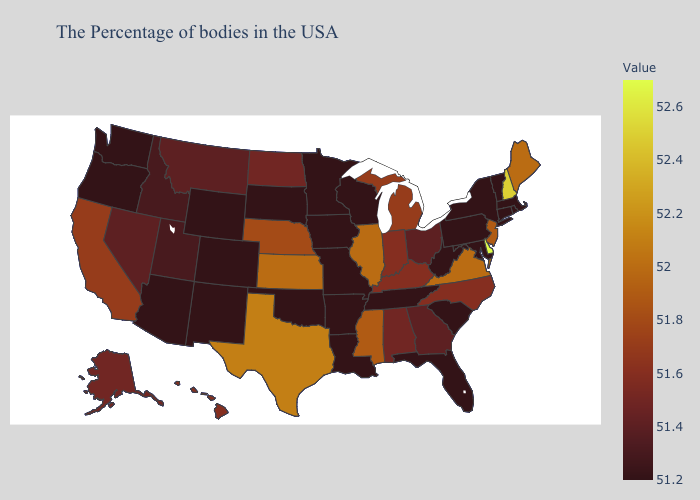Among the states that border Missouri , which have the highest value?
Quick response, please. Illinois, Kansas. Does the map have missing data?
Quick response, please. No. Which states have the lowest value in the USA?
Concise answer only. Massachusetts, Rhode Island, Vermont, Connecticut, New York, Maryland, Pennsylvania, South Carolina, West Virginia, Florida, Tennessee, Wisconsin, Louisiana, Missouri, Arkansas, Minnesota, Iowa, Oklahoma, South Dakota, Wyoming, Colorado, New Mexico, Arizona, Washington, Oregon. 